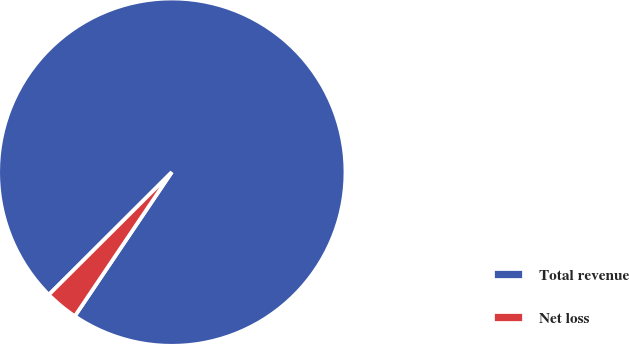Convert chart to OTSL. <chart><loc_0><loc_0><loc_500><loc_500><pie_chart><fcel>Total revenue<fcel>Net loss<nl><fcel>96.91%<fcel>3.09%<nl></chart> 